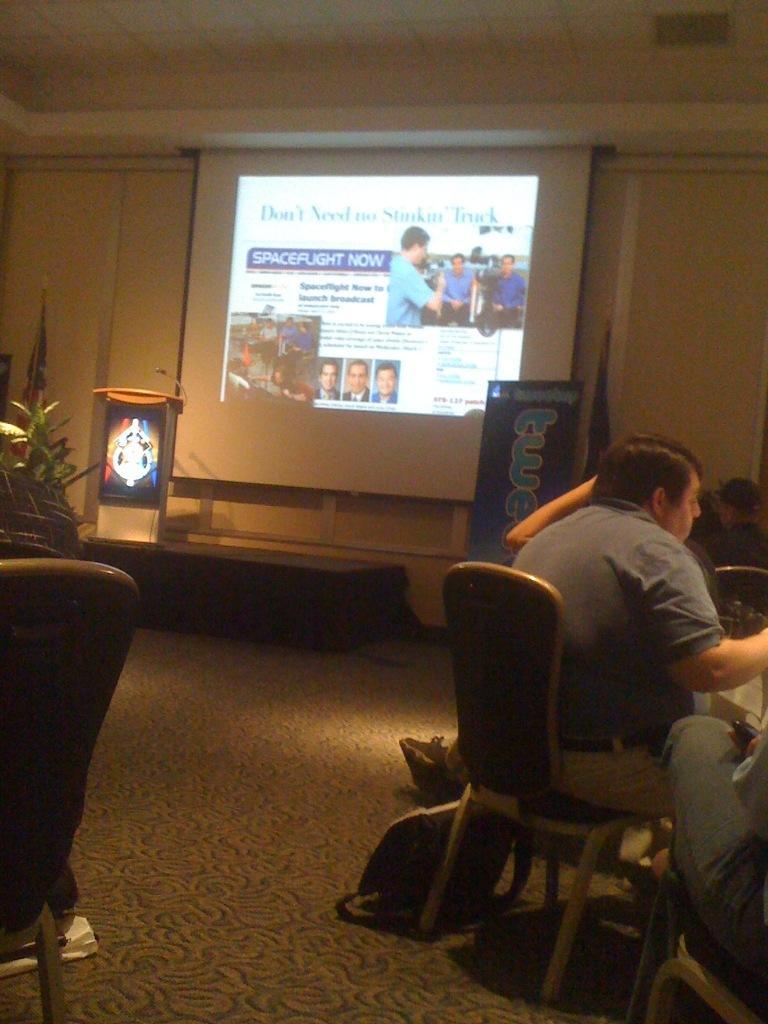Describe this image in one or two sentences. This image is clicked inside a room. There are chairs on which people are sitting. There is a projector screen in the middle. That is a podium near the screen. There is flag on the right left side. There is a plant on the left side. 